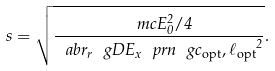<formula> <loc_0><loc_0><loc_500><loc_500>s = \sqrt { \frac { \ m c { E } _ { 0 } ^ { 2 } / 4 } { \ a b r { _ { r } { \ g D E _ { x } \ p r n { \ g c _ { \text {opt} } , \ell _ { \text {opt} } } } ^ { 2 } } } } .</formula> 